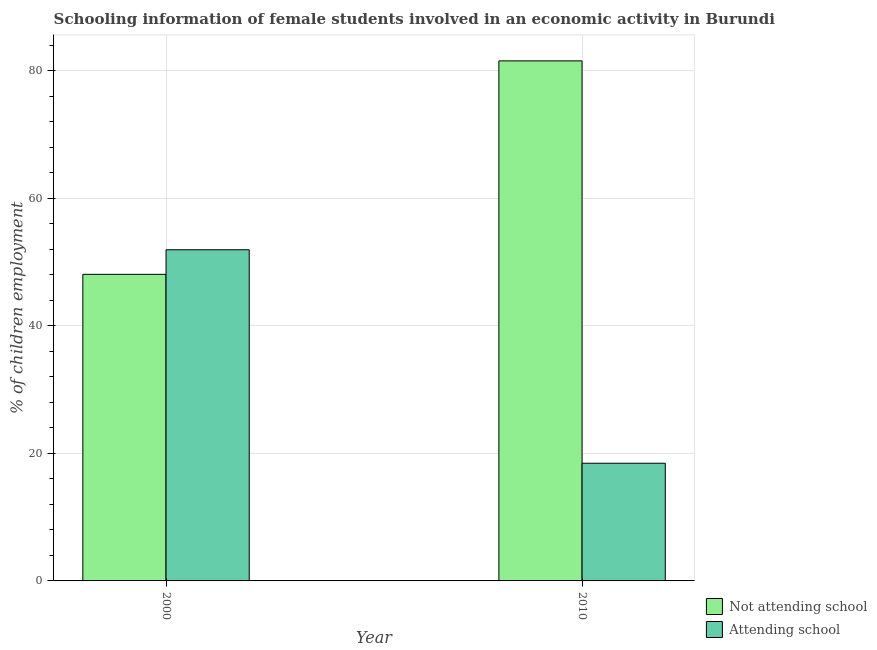How many different coloured bars are there?
Give a very brief answer. 2. Are the number of bars per tick equal to the number of legend labels?
Offer a very short reply. Yes. Are the number of bars on each tick of the X-axis equal?
Provide a succinct answer. Yes. How many bars are there on the 2nd tick from the right?
Your answer should be very brief. 2. In how many cases, is the number of bars for a given year not equal to the number of legend labels?
Offer a terse response. 0. What is the percentage of employed females who are not attending school in 2010?
Ensure brevity in your answer.  81.54. Across all years, what is the maximum percentage of employed females who are attending school?
Your answer should be very brief. 51.93. Across all years, what is the minimum percentage of employed females who are not attending school?
Keep it short and to the point. 48.07. In which year was the percentage of employed females who are attending school maximum?
Offer a very short reply. 2000. In which year was the percentage of employed females who are attending school minimum?
Offer a terse response. 2010. What is the total percentage of employed females who are not attending school in the graph?
Your answer should be compact. 129.62. What is the difference between the percentage of employed females who are not attending school in 2000 and that in 2010?
Offer a very short reply. -33.47. What is the difference between the percentage of employed females who are attending school in 2010 and the percentage of employed females who are not attending school in 2000?
Provide a succinct answer. -33.47. What is the average percentage of employed females who are attending school per year?
Provide a succinct answer. 35.19. In the year 2010, what is the difference between the percentage of employed females who are attending school and percentage of employed females who are not attending school?
Your answer should be very brief. 0. In how many years, is the percentage of employed females who are attending school greater than 4 %?
Your answer should be compact. 2. What is the ratio of the percentage of employed females who are not attending school in 2000 to that in 2010?
Provide a succinct answer. 0.59. Is the percentage of employed females who are attending school in 2000 less than that in 2010?
Keep it short and to the point. No. In how many years, is the percentage of employed females who are attending school greater than the average percentage of employed females who are attending school taken over all years?
Offer a terse response. 1. What does the 2nd bar from the left in 2010 represents?
Your answer should be very brief. Attending school. What does the 2nd bar from the right in 2000 represents?
Provide a short and direct response. Not attending school. How many bars are there?
Offer a terse response. 4. Are all the bars in the graph horizontal?
Your answer should be compact. No. What is the difference between two consecutive major ticks on the Y-axis?
Your answer should be very brief. 20. Does the graph contain grids?
Your response must be concise. Yes. Where does the legend appear in the graph?
Make the answer very short. Bottom right. How many legend labels are there?
Your response must be concise. 2. What is the title of the graph?
Offer a terse response. Schooling information of female students involved in an economic activity in Burundi. Does "Nonresident" appear as one of the legend labels in the graph?
Your response must be concise. No. What is the label or title of the X-axis?
Provide a short and direct response. Year. What is the label or title of the Y-axis?
Give a very brief answer. % of children employment. What is the % of children employment in Not attending school in 2000?
Give a very brief answer. 48.07. What is the % of children employment of Attending school in 2000?
Your response must be concise. 51.93. What is the % of children employment of Not attending school in 2010?
Ensure brevity in your answer.  81.54. What is the % of children employment in Attending school in 2010?
Offer a very short reply. 18.46. Across all years, what is the maximum % of children employment in Not attending school?
Your answer should be very brief. 81.54. Across all years, what is the maximum % of children employment in Attending school?
Your response must be concise. 51.93. Across all years, what is the minimum % of children employment in Not attending school?
Provide a short and direct response. 48.07. Across all years, what is the minimum % of children employment of Attending school?
Ensure brevity in your answer.  18.46. What is the total % of children employment in Not attending school in the graph?
Your answer should be compact. 129.62. What is the total % of children employment in Attending school in the graph?
Offer a terse response. 70.38. What is the difference between the % of children employment of Not attending school in 2000 and that in 2010?
Offer a very short reply. -33.47. What is the difference between the % of children employment of Attending school in 2000 and that in 2010?
Provide a succinct answer. 33.47. What is the difference between the % of children employment in Not attending school in 2000 and the % of children employment in Attending school in 2010?
Give a very brief answer. 29.62. What is the average % of children employment of Not attending school per year?
Keep it short and to the point. 64.81. What is the average % of children employment in Attending school per year?
Ensure brevity in your answer.  35.19. In the year 2000, what is the difference between the % of children employment in Not attending school and % of children employment in Attending school?
Your answer should be very brief. -3.85. In the year 2010, what is the difference between the % of children employment of Not attending school and % of children employment of Attending school?
Keep it short and to the point. 63.09. What is the ratio of the % of children employment in Not attending school in 2000 to that in 2010?
Your answer should be compact. 0.59. What is the ratio of the % of children employment in Attending school in 2000 to that in 2010?
Your answer should be compact. 2.81. What is the difference between the highest and the second highest % of children employment in Not attending school?
Ensure brevity in your answer.  33.47. What is the difference between the highest and the second highest % of children employment of Attending school?
Make the answer very short. 33.47. What is the difference between the highest and the lowest % of children employment of Not attending school?
Offer a terse response. 33.47. What is the difference between the highest and the lowest % of children employment in Attending school?
Give a very brief answer. 33.47. 